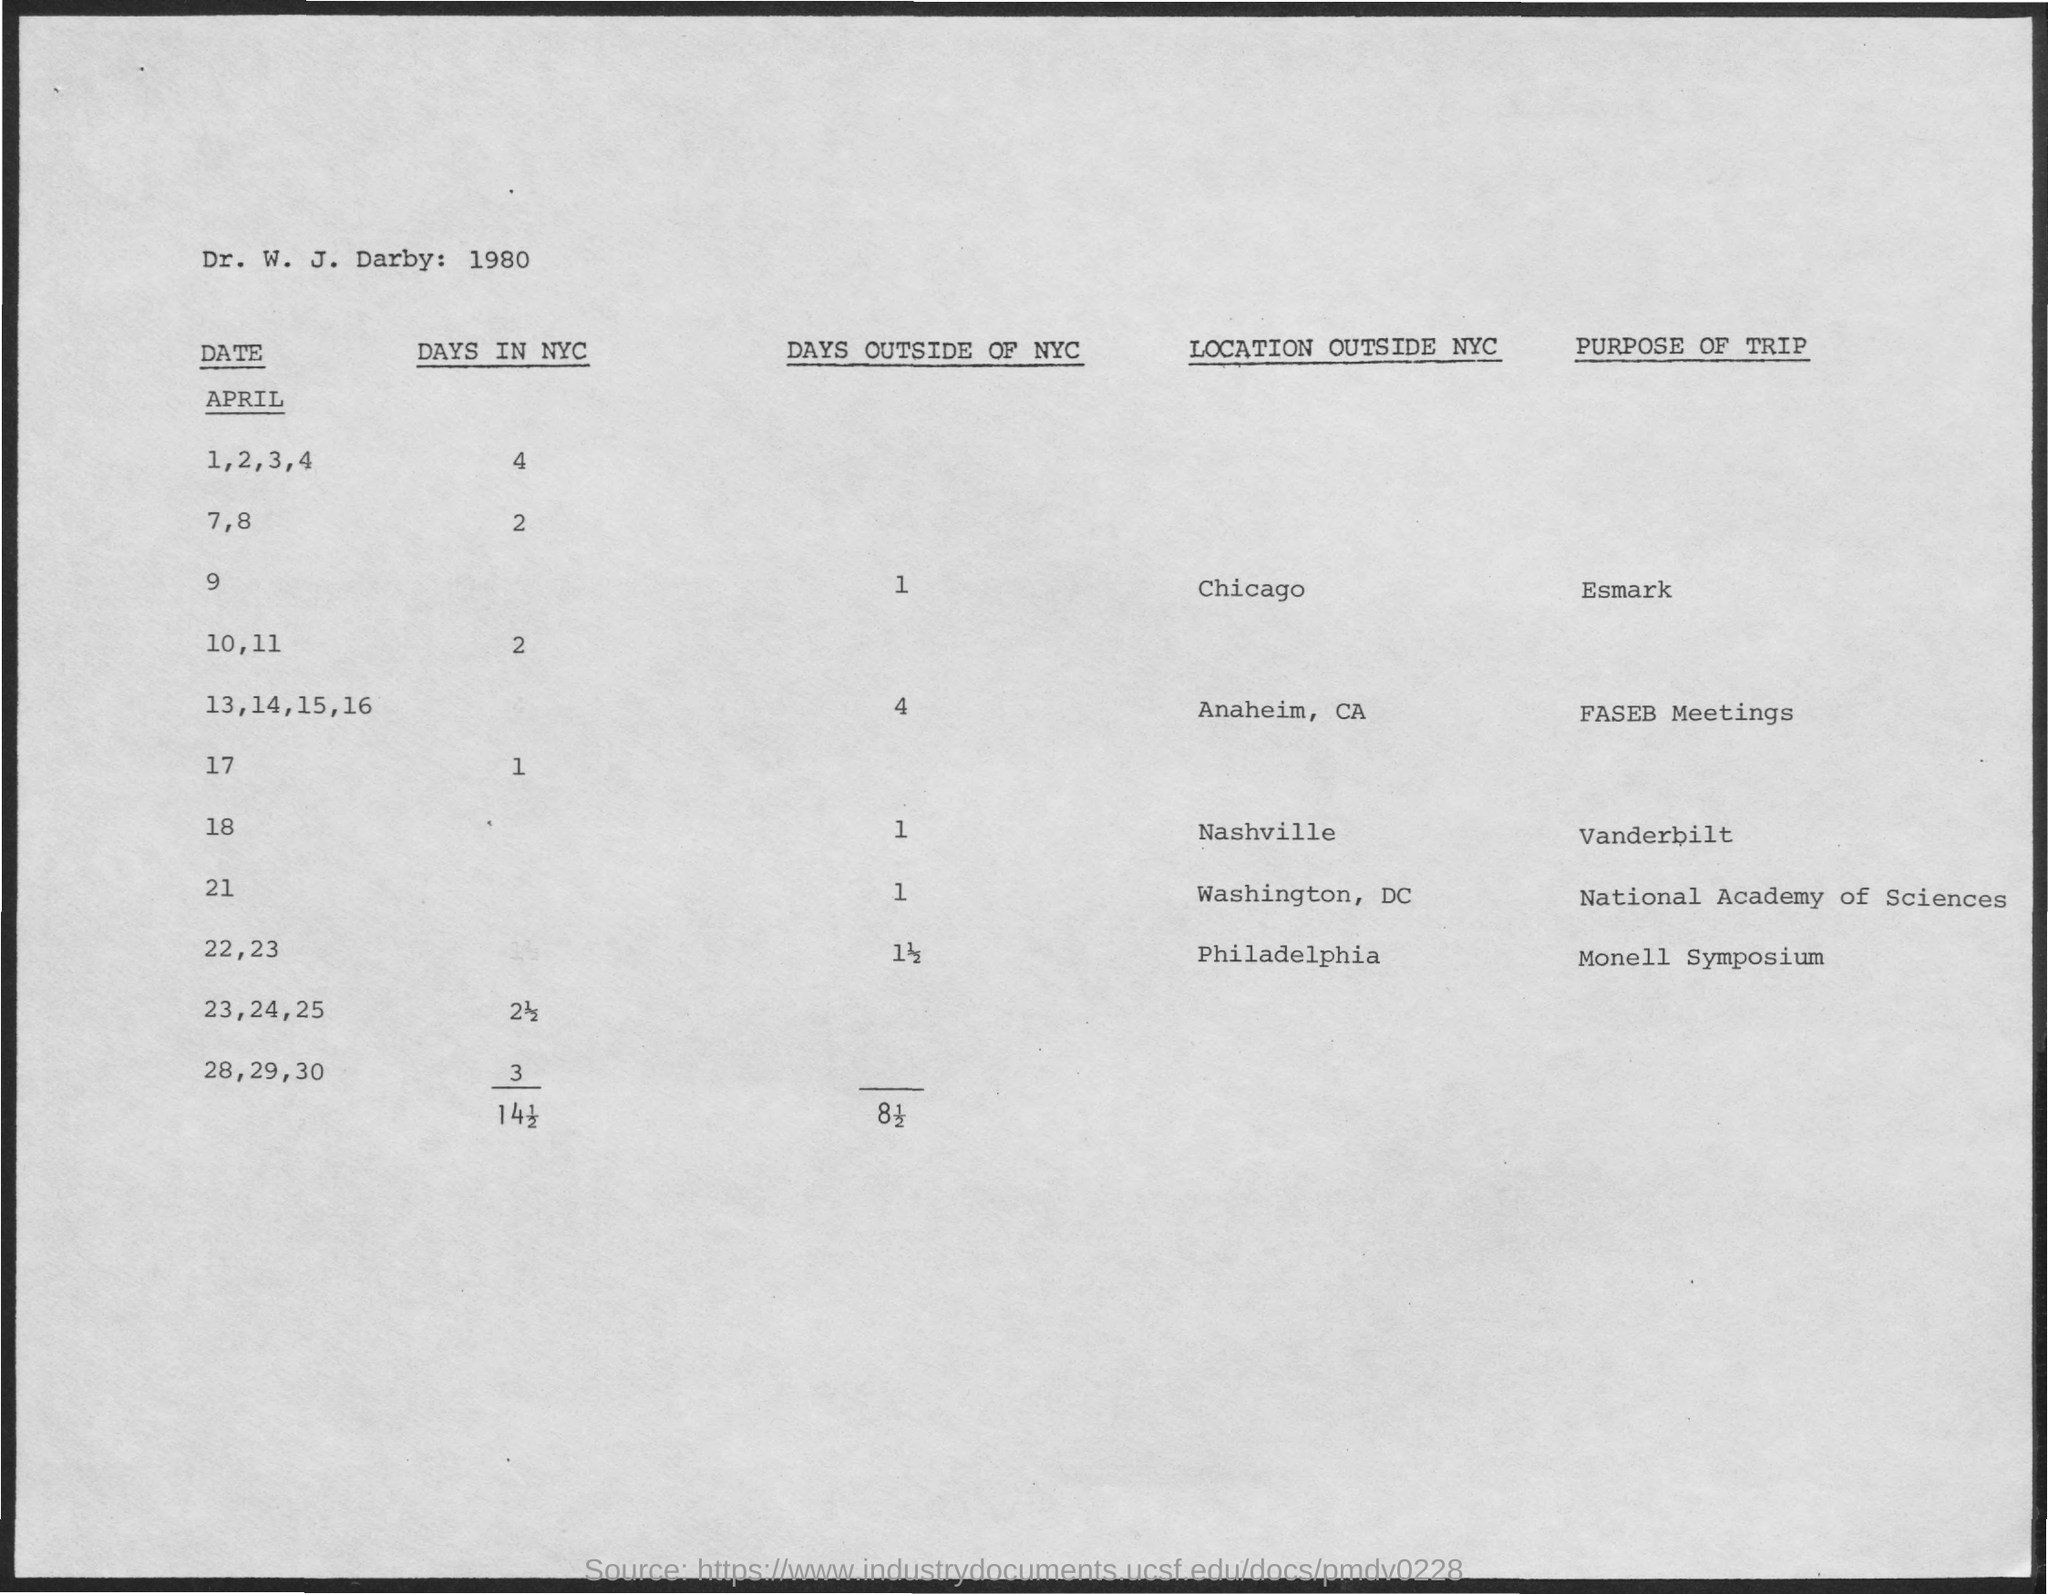Which year is mentioned in the document?
Your answer should be compact. 1980. What is the purpose of trip to Anaheim, CA?
Make the answer very short. FASEB Meetings. Where is the Monell Symposium going to be held?
Give a very brief answer. Philadelphia. On which date in April is the trip to Vanderbilt?
Offer a very short reply. 18. 